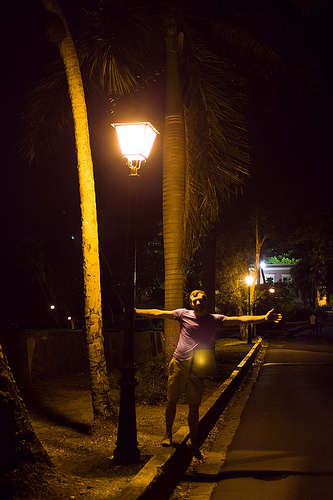<image>
Is there a light behind the human? No. The light is not behind the human. From this viewpoint, the light appears to be positioned elsewhere in the scene. 